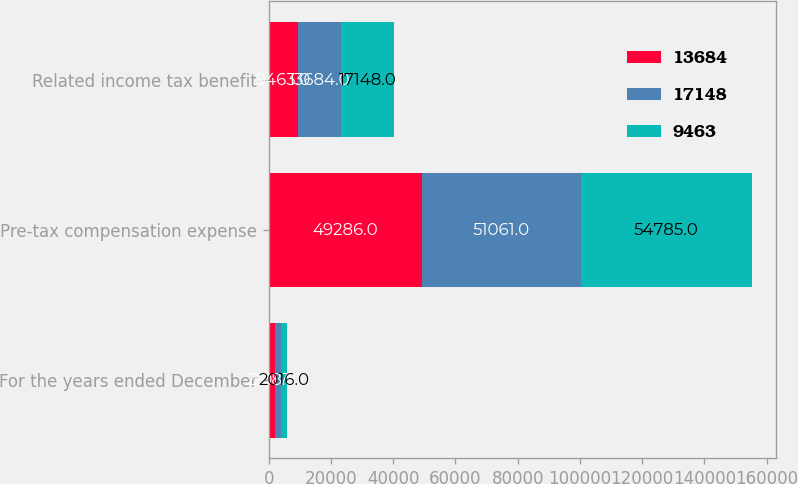Convert chart to OTSL. <chart><loc_0><loc_0><loc_500><loc_500><stacked_bar_chart><ecel><fcel>For the years ended December<fcel>Pre-tax compensation expense<fcel>Related income tax benefit<nl><fcel>13684<fcel>2018<fcel>49286<fcel>9463<nl><fcel>17148<fcel>2017<fcel>51061<fcel>13684<nl><fcel>9463<fcel>2016<fcel>54785<fcel>17148<nl></chart> 